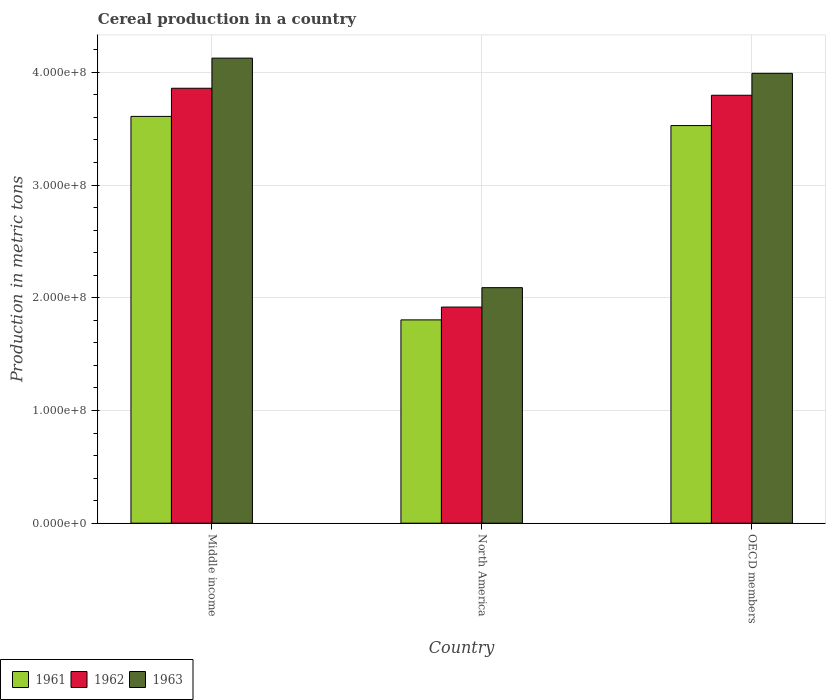Are the number of bars per tick equal to the number of legend labels?
Keep it short and to the point. Yes. Are the number of bars on each tick of the X-axis equal?
Your answer should be very brief. Yes. How many bars are there on the 1st tick from the left?
Your response must be concise. 3. What is the label of the 3rd group of bars from the left?
Make the answer very short. OECD members. What is the total cereal production in 1963 in North America?
Offer a terse response. 2.09e+08. Across all countries, what is the maximum total cereal production in 1963?
Provide a succinct answer. 4.13e+08. Across all countries, what is the minimum total cereal production in 1962?
Make the answer very short. 1.92e+08. In which country was the total cereal production in 1963 minimum?
Make the answer very short. North America. What is the total total cereal production in 1961 in the graph?
Offer a terse response. 8.94e+08. What is the difference between the total cereal production in 1961 in Middle income and that in North America?
Your response must be concise. 1.81e+08. What is the difference between the total cereal production in 1963 in OECD members and the total cereal production in 1961 in Middle income?
Ensure brevity in your answer.  3.82e+07. What is the average total cereal production in 1962 per country?
Make the answer very short. 3.19e+08. What is the difference between the total cereal production of/in 1961 and total cereal production of/in 1963 in Middle income?
Keep it short and to the point. -5.17e+07. What is the ratio of the total cereal production in 1963 in Middle income to that in North America?
Your answer should be very brief. 1.97. Is the difference between the total cereal production in 1961 in Middle income and North America greater than the difference between the total cereal production in 1963 in Middle income and North America?
Your answer should be very brief. No. What is the difference between the highest and the second highest total cereal production in 1962?
Offer a very short reply. 6.21e+06. What is the difference between the highest and the lowest total cereal production in 1961?
Make the answer very short. 1.81e+08. Is the sum of the total cereal production in 1961 in Middle income and OECD members greater than the maximum total cereal production in 1963 across all countries?
Make the answer very short. Yes. Are all the bars in the graph horizontal?
Make the answer very short. No. What is the difference between two consecutive major ticks on the Y-axis?
Offer a very short reply. 1.00e+08. Are the values on the major ticks of Y-axis written in scientific E-notation?
Make the answer very short. Yes. What is the title of the graph?
Keep it short and to the point. Cereal production in a country. What is the label or title of the Y-axis?
Ensure brevity in your answer.  Production in metric tons. What is the Production in metric tons in 1961 in Middle income?
Provide a succinct answer. 3.61e+08. What is the Production in metric tons in 1962 in Middle income?
Your answer should be very brief. 3.86e+08. What is the Production in metric tons in 1963 in Middle income?
Your response must be concise. 4.13e+08. What is the Production in metric tons in 1961 in North America?
Offer a terse response. 1.80e+08. What is the Production in metric tons in 1962 in North America?
Ensure brevity in your answer.  1.92e+08. What is the Production in metric tons in 1963 in North America?
Provide a short and direct response. 2.09e+08. What is the Production in metric tons of 1961 in OECD members?
Make the answer very short. 3.53e+08. What is the Production in metric tons of 1962 in OECD members?
Your answer should be compact. 3.80e+08. What is the Production in metric tons of 1963 in OECD members?
Make the answer very short. 3.99e+08. Across all countries, what is the maximum Production in metric tons in 1961?
Give a very brief answer. 3.61e+08. Across all countries, what is the maximum Production in metric tons of 1962?
Your response must be concise. 3.86e+08. Across all countries, what is the maximum Production in metric tons of 1963?
Offer a terse response. 4.13e+08. Across all countries, what is the minimum Production in metric tons in 1961?
Provide a succinct answer. 1.80e+08. Across all countries, what is the minimum Production in metric tons in 1962?
Provide a short and direct response. 1.92e+08. Across all countries, what is the minimum Production in metric tons in 1963?
Offer a terse response. 2.09e+08. What is the total Production in metric tons of 1961 in the graph?
Your answer should be very brief. 8.94e+08. What is the total Production in metric tons of 1962 in the graph?
Your answer should be compact. 9.57e+08. What is the total Production in metric tons of 1963 in the graph?
Your response must be concise. 1.02e+09. What is the difference between the Production in metric tons in 1961 in Middle income and that in North America?
Ensure brevity in your answer.  1.81e+08. What is the difference between the Production in metric tons of 1962 in Middle income and that in North America?
Your answer should be compact. 1.94e+08. What is the difference between the Production in metric tons in 1963 in Middle income and that in North America?
Ensure brevity in your answer.  2.04e+08. What is the difference between the Production in metric tons of 1961 in Middle income and that in OECD members?
Keep it short and to the point. 8.13e+06. What is the difference between the Production in metric tons of 1962 in Middle income and that in OECD members?
Provide a short and direct response. 6.21e+06. What is the difference between the Production in metric tons in 1963 in Middle income and that in OECD members?
Offer a very short reply. 1.35e+07. What is the difference between the Production in metric tons of 1961 in North America and that in OECD members?
Your answer should be compact. -1.72e+08. What is the difference between the Production in metric tons in 1962 in North America and that in OECD members?
Provide a short and direct response. -1.88e+08. What is the difference between the Production in metric tons of 1963 in North America and that in OECD members?
Your answer should be very brief. -1.90e+08. What is the difference between the Production in metric tons of 1961 in Middle income and the Production in metric tons of 1962 in North America?
Offer a terse response. 1.69e+08. What is the difference between the Production in metric tons in 1961 in Middle income and the Production in metric tons in 1963 in North America?
Offer a terse response. 1.52e+08. What is the difference between the Production in metric tons in 1962 in Middle income and the Production in metric tons in 1963 in North America?
Give a very brief answer. 1.77e+08. What is the difference between the Production in metric tons of 1961 in Middle income and the Production in metric tons of 1962 in OECD members?
Your answer should be compact. -1.88e+07. What is the difference between the Production in metric tons in 1961 in Middle income and the Production in metric tons in 1963 in OECD members?
Your answer should be compact. -3.82e+07. What is the difference between the Production in metric tons of 1962 in Middle income and the Production in metric tons of 1963 in OECD members?
Give a very brief answer. -1.32e+07. What is the difference between the Production in metric tons in 1961 in North America and the Production in metric tons in 1962 in OECD members?
Offer a very short reply. -1.99e+08. What is the difference between the Production in metric tons of 1961 in North America and the Production in metric tons of 1963 in OECD members?
Your response must be concise. -2.19e+08. What is the difference between the Production in metric tons of 1962 in North America and the Production in metric tons of 1963 in OECD members?
Your answer should be compact. -2.07e+08. What is the average Production in metric tons of 1961 per country?
Provide a short and direct response. 2.98e+08. What is the average Production in metric tons of 1962 per country?
Provide a short and direct response. 3.19e+08. What is the average Production in metric tons of 1963 per country?
Provide a short and direct response. 3.40e+08. What is the difference between the Production in metric tons in 1961 and Production in metric tons in 1962 in Middle income?
Ensure brevity in your answer.  -2.50e+07. What is the difference between the Production in metric tons in 1961 and Production in metric tons in 1963 in Middle income?
Your response must be concise. -5.17e+07. What is the difference between the Production in metric tons in 1962 and Production in metric tons in 1963 in Middle income?
Keep it short and to the point. -2.67e+07. What is the difference between the Production in metric tons of 1961 and Production in metric tons of 1962 in North America?
Offer a very short reply. -1.14e+07. What is the difference between the Production in metric tons in 1961 and Production in metric tons in 1963 in North America?
Give a very brief answer. -2.86e+07. What is the difference between the Production in metric tons of 1962 and Production in metric tons of 1963 in North America?
Your response must be concise. -1.72e+07. What is the difference between the Production in metric tons of 1961 and Production in metric tons of 1962 in OECD members?
Offer a terse response. -2.69e+07. What is the difference between the Production in metric tons in 1961 and Production in metric tons in 1963 in OECD members?
Provide a short and direct response. -4.63e+07. What is the difference between the Production in metric tons of 1962 and Production in metric tons of 1963 in OECD members?
Offer a very short reply. -1.94e+07. What is the ratio of the Production in metric tons in 1961 in Middle income to that in North America?
Give a very brief answer. 2. What is the ratio of the Production in metric tons in 1962 in Middle income to that in North America?
Provide a short and direct response. 2.01. What is the ratio of the Production in metric tons in 1963 in Middle income to that in North America?
Make the answer very short. 1.97. What is the ratio of the Production in metric tons in 1961 in Middle income to that in OECD members?
Provide a short and direct response. 1.02. What is the ratio of the Production in metric tons in 1962 in Middle income to that in OECD members?
Make the answer very short. 1.02. What is the ratio of the Production in metric tons of 1963 in Middle income to that in OECD members?
Offer a very short reply. 1.03. What is the ratio of the Production in metric tons of 1961 in North America to that in OECD members?
Your response must be concise. 0.51. What is the ratio of the Production in metric tons of 1962 in North America to that in OECD members?
Your answer should be compact. 0.51. What is the ratio of the Production in metric tons in 1963 in North America to that in OECD members?
Keep it short and to the point. 0.52. What is the difference between the highest and the second highest Production in metric tons in 1961?
Ensure brevity in your answer.  8.13e+06. What is the difference between the highest and the second highest Production in metric tons in 1962?
Make the answer very short. 6.21e+06. What is the difference between the highest and the second highest Production in metric tons of 1963?
Give a very brief answer. 1.35e+07. What is the difference between the highest and the lowest Production in metric tons of 1961?
Make the answer very short. 1.81e+08. What is the difference between the highest and the lowest Production in metric tons in 1962?
Offer a very short reply. 1.94e+08. What is the difference between the highest and the lowest Production in metric tons in 1963?
Ensure brevity in your answer.  2.04e+08. 